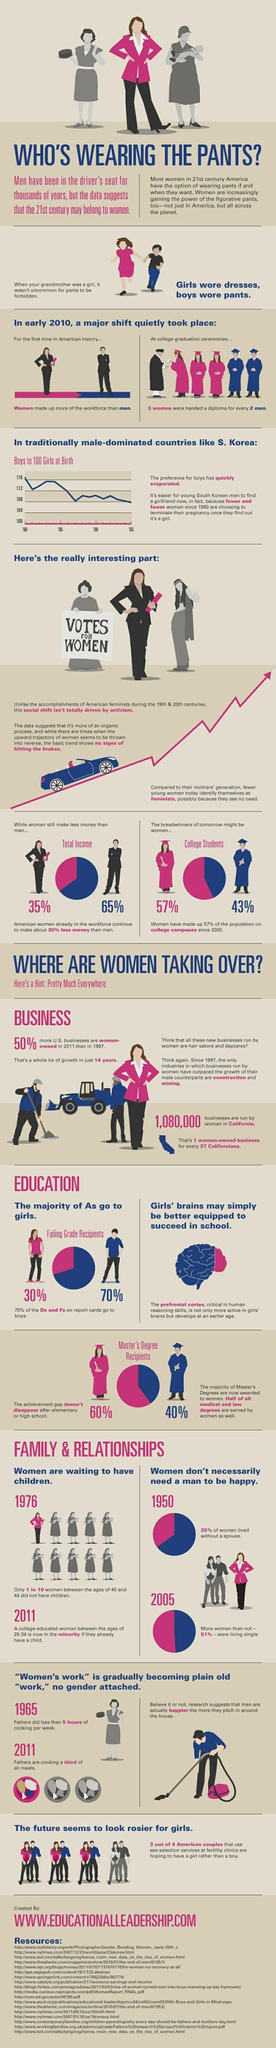Specify some key components in this picture. Out of three meals, women cook two, with the exception of number 3. From 1950 to 2005, there was a 16% increase in the percentage of single women. In the past 21 years, the percentage of women enrolled in college has increased from 35% to 57%. 